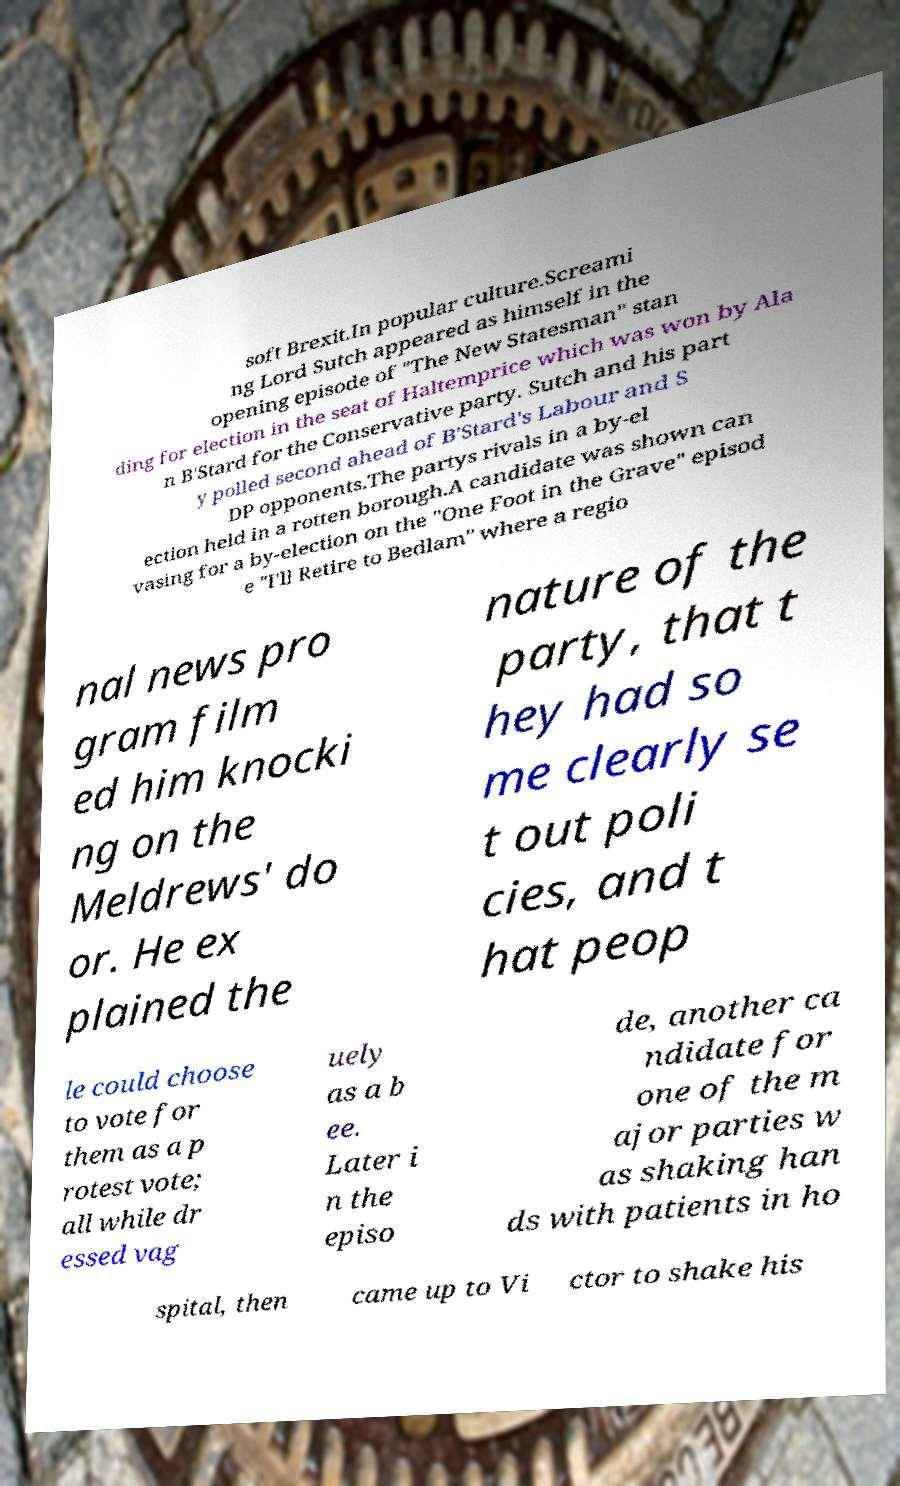What messages or text are displayed in this image? I need them in a readable, typed format. soft Brexit.In popular culture.Screami ng Lord Sutch appeared as himself in the opening episode of "The New Statesman" stan ding for election in the seat of Haltemprice which was won by Ala n B'Stard for the Conservative party. Sutch and his part y polled second ahead of B'Stard's Labour and S DP opponents.The partys rivals in a by-el ection held in a rotten borough.A candidate was shown can vasing for a by-election on the "One Foot in the Grave" episod e "I'll Retire to Bedlam" where a regio nal news pro gram film ed him knocki ng on the Meldrews' do or. He ex plained the nature of the party, that t hey had so me clearly se t out poli cies, and t hat peop le could choose to vote for them as a p rotest vote; all while dr essed vag uely as a b ee. Later i n the episo de, another ca ndidate for one of the m ajor parties w as shaking han ds with patients in ho spital, then came up to Vi ctor to shake his 